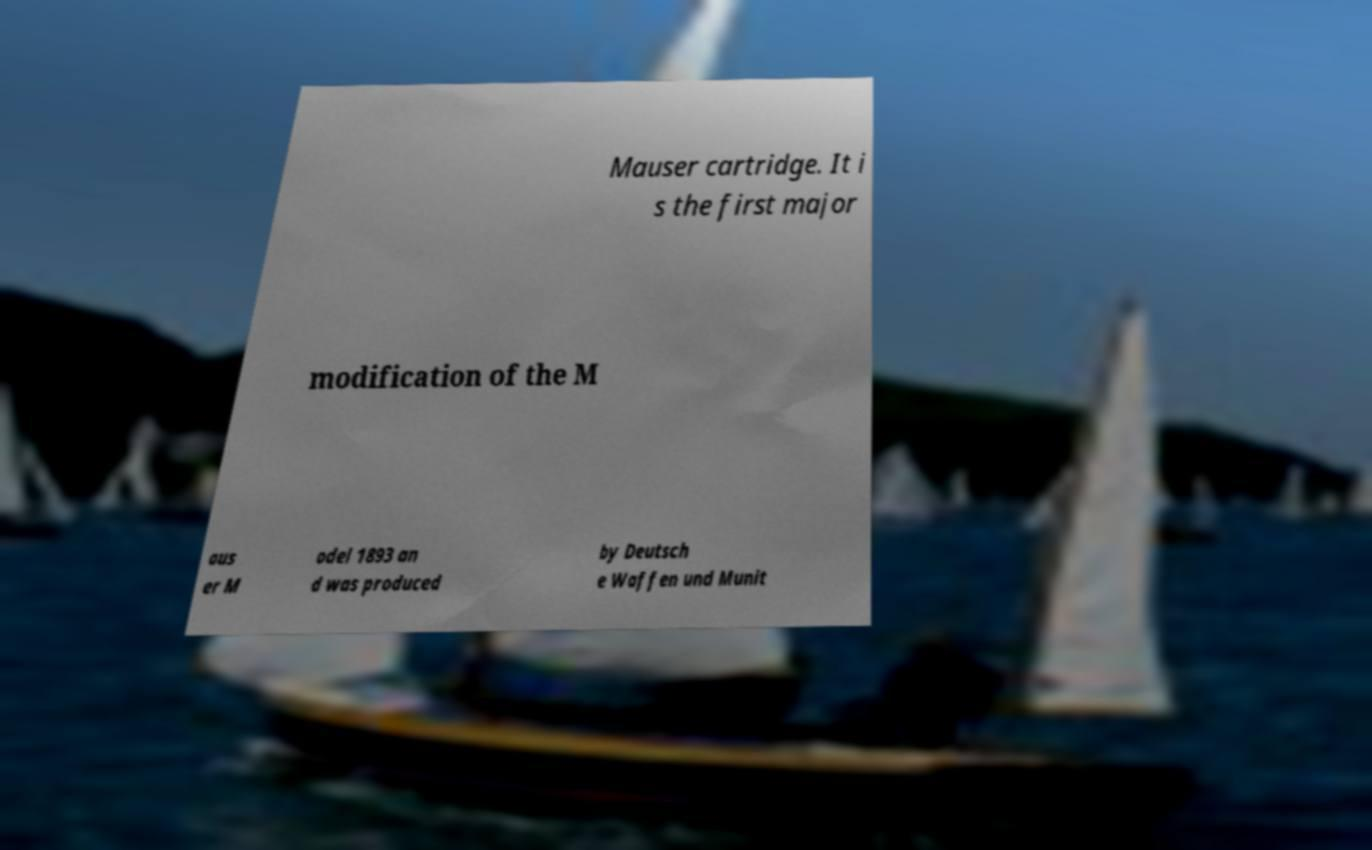Could you assist in decoding the text presented in this image and type it out clearly? Mauser cartridge. It i s the first major modification of the M aus er M odel 1893 an d was produced by Deutsch e Waffen und Munit 